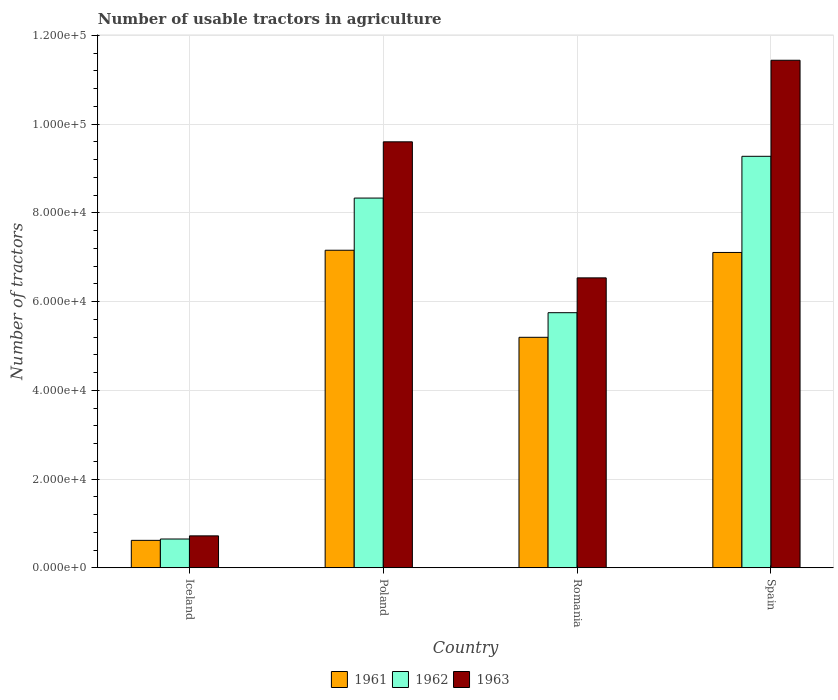Are the number of bars per tick equal to the number of legend labels?
Your response must be concise. Yes. What is the label of the 1st group of bars from the left?
Make the answer very short. Iceland. What is the number of usable tractors in agriculture in 1961 in Iceland?
Provide a short and direct response. 6177. Across all countries, what is the maximum number of usable tractors in agriculture in 1961?
Give a very brief answer. 7.16e+04. Across all countries, what is the minimum number of usable tractors in agriculture in 1962?
Your answer should be very brief. 6479. What is the total number of usable tractors in agriculture in 1962 in the graph?
Provide a succinct answer. 2.40e+05. What is the difference between the number of usable tractors in agriculture in 1961 in Iceland and that in Spain?
Offer a very short reply. -6.49e+04. What is the difference between the number of usable tractors in agriculture in 1963 in Poland and the number of usable tractors in agriculture in 1962 in Romania?
Ensure brevity in your answer.  3.85e+04. What is the average number of usable tractors in agriculture in 1963 per country?
Your response must be concise. 7.07e+04. What is the difference between the number of usable tractors in agriculture of/in 1961 and number of usable tractors in agriculture of/in 1962 in Iceland?
Keep it short and to the point. -302. In how many countries, is the number of usable tractors in agriculture in 1961 greater than 100000?
Offer a terse response. 0. What is the ratio of the number of usable tractors in agriculture in 1961 in Romania to that in Spain?
Keep it short and to the point. 0.73. Is the number of usable tractors in agriculture in 1963 in Poland less than that in Spain?
Keep it short and to the point. Yes. What is the difference between the highest and the second highest number of usable tractors in agriculture in 1961?
Make the answer very short. -1.96e+04. What is the difference between the highest and the lowest number of usable tractors in agriculture in 1962?
Offer a very short reply. 8.63e+04. Is the sum of the number of usable tractors in agriculture in 1963 in Poland and Spain greater than the maximum number of usable tractors in agriculture in 1962 across all countries?
Your response must be concise. Yes. What does the 3rd bar from the right in Spain represents?
Ensure brevity in your answer.  1961. Is it the case that in every country, the sum of the number of usable tractors in agriculture in 1963 and number of usable tractors in agriculture in 1961 is greater than the number of usable tractors in agriculture in 1962?
Your answer should be very brief. Yes. Are all the bars in the graph horizontal?
Keep it short and to the point. No. What is the difference between two consecutive major ticks on the Y-axis?
Your answer should be compact. 2.00e+04. Are the values on the major ticks of Y-axis written in scientific E-notation?
Offer a terse response. Yes. Does the graph contain any zero values?
Ensure brevity in your answer.  No. Does the graph contain grids?
Ensure brevity in your answer.  Yes. How are the legend labels stacked?
Your answer should be very brief. Horizontal. What is the title of the graph?
Your response must be concise. Number of usable tractors in agriculture. Does "1995" appear as one of the legend labels in the graph?
Make the answer very short. No. What is the label or title of the X-axis?
Offer a very short reply. Country. What is the label or title of the Y-axis?
Make the answer very short. Number of tractors. What is the Number of tractors in 1961 in Iceland?
Give a very brief answer. 6177. What is the Number of tractors of 1962 in Iceland?
Make the answer very short. 6479. What is the Number of tractors in 1963 in Iceland?
Your response must be concise. 7187. What is the Number of tractors of 1961 in Poland?
Provide a succinct answer. 7.16e+04. What is the Number of tractors in 1962 in Poland?
Offer a terse response. 8.33e+04. What is the Number of tractors in 1963 in Poland?
Offer a terse response. 9.60e+04. What is the Number of tractors in 1961 in Romania?
Your response must be concise. 5.20e+04. What is the Number of tractors of 1962 in Romania?
Provide a succinct answer. 5.75e+04. What is the Number of tractors of 1963 in Romania?
Your answer should be very brief. 6.54e+04. What is the Number of tractors in 1961 in Spain?
Provide a short and direct response. 7.11e+04. What is the Number of tractors of 1962 in Spain?
Keep it short and to the point. 9.28e+04. What is the Number of tractors of 1963 in Spain?
Keep it short and to the point. 1.14e+05. Across all countries, what is the maximum Number of tractors of 1961?
Your response must be concise. 7.16e+04. Across all countries, what is the maximum Number of tractors of 1962?
Make the answer very short. 9.28e+04. Across all countries, what is the maximum Number of tractors of 1963?
Your answer should be compact. 1.14e+05. Across all countries, what is the minimum Number of tractors in 1961?
Keep it short and to the point. 6177. Across all countries, what is the minimum Number of tractors in 1962?
Offer a terse response. 6479. Across all countries, what is the minimum Number of tractors of 1963?
Your answer should be compact. 7187. What is the total Number of tractors of 1961 in the graph?
Ensure brevity in your answer.  2.01e+05. What is the total Number of tractors in 1962 in the graph?
Make the answer very short. 2.40e+05. What is the total Number of tractors of 1963 in the graph?
Provide a short and direct response. 2.83e+05. What is the difference between the Number of tractors in 1961 in Iceland and that in Poland?
Provide a short and direct response. -6.54e+04. What is the difference between the Number of tractors of 1962 in Iceland and that in Poland?
Your answer should be very brief. -7.69e+04. What is the difference between the Number of tractors in 1963 in Iceland and that in Poland?
Make the answer very short. -8.88e+04. What is the difference between the Number of tractors of 1961 in Iceland and that in Romania?
Ensure brevity in your answer.  -4.58e+04. What is the difference between the Number of tractors of 1962 in Iceland and that in Romania?
Your answer should be very brief. -5.10e+04. What is the difference between the Number of tractors in 1963 in Iceland and that in Romania?
Offer a terse response. -5.82e+04. What is the difference between the Number of tractors of 1961 in Iceland and that in Spain?
Make the answer very short. -6.49e+04. What is the difference between the Number of tractors in 1962 in Iceland and that in Spain?
Give a very brief answer. -8.63e+04. What is the difference between the Number of tractors of 1963 in Iceland and that in Spain?
Make the answer very short. -1.07e+05. What is the difference between the Number of tractors in 1961 in Poland and that in Romania?
Provide a succinct answer. 1.96e+04. What is the difference between the Number of tractors of 1962 in Poland and that in Romania?
Your response must be concise. 2.58e+04. What is the difference between the Number of tractors of 1963 in Poland and that in Romania?
Keep it short and to the point. 3.07e+04. What is the difference between the Number of tractors in 1961 in Poland and that in Spain?
Provide a succinct answer. 500. What is the difference between the Number of tractors in 1962 in Poland and that in Spain?
Provide a succinct answer. -9414. What is the difference between the Number of tractors of 1963 in Poland and that in Spain?
Make the answer very short. -1.84e+04. What is the difference between the Number of tractors in 1961 in Romania and that in Spain?
Ensure brevity in your answer.  -1.91e+04. What is the difference between the Number of tractors in 1962 in Romania and that in Spain?
Give a very brief answer. -3.53e+04. What is the difference between the Number of tractors of 1963 in Romania and that in Spain?
Provide a succinct answer. -4.91e+04. What is the difference between the Number of tractors in 1961 in Iceland and the Number of tractors in 1962 in Poland?
Your answer should be very brief. -7.72e+04. What is the difference between the Number of tractors in 1961 in Iceland and the Number of tractors in 1963 in Poland?
Provide a succinct answer. -8.98e+04. What is the difference between the Number of tractors of 1962 in Iceland and the Number of tractors of 1963 in Poland?
Provide a short and direct response. -8.95e+04. What is the difference between the Number of tractors in 1961 in Iceland and the Number of tractors in 1962 in Romania?
Provide a short and direct response. -5.13e+04. What is the difference between the Number of tractors in 1961 in Iceland and the Number of tractors in 1963 in Romania?
Offer a terse response. -5.92e+04. What is the difference between the Number of tractors of 1962 in Iceland and the Number of tractors of 1963 in Romania?
Provide a short and direct response. -5.89e+04. What is the difference between the Number of tractors of 1961 in Iceland and the Number of tractors of 1962 in Spain?
Provide a succinct answer. -8.66e+04. What is the difference between the Number of tractors in 1961 in Iceland and the Number of tractors in 1963 in Spain?
Keep it short and to the point. -1.08e+05. What is the difference between the Number of tractors in 1962 in Iceland and the Number of tractors in 1963 in Spain?
Your answer should be compact. -1.08e+05. What is the difference between the Number of tractors in 1961 in Poland and the Number of tractors in 1962 in Romania?
Your answer should be very brief. 1.41e+04. What is the difference between the Number of tractors in 1961 in Poland and the Number of tractors in 1963 in Romania?
Your response must be concise. 6226. What is the difference between the Number of tractors of 1962 in Poland and the Number of tractors of 1963 in Romania?
Offer a very short reply. 1.80e+04. What is the difference between the Number of tractors of 1961 in Poland and the Number of tractors of 1962 in Spain?
Your answer should be compact. -2.12e+04. What is the difference between the Number of tractors of 1961 in Poland and the Number of tractors of 1963 in Spain?
Provide a succinct answer. -4.28e+04. What is the difference between the Number of tractors of 1962 in Poland and the Number of tractors of 1963 in Spain?
Keep it short and to the point. -3.11e+04. What is the difference between the Number of tractors in 1961 in Romania and the Number of tractors in 1962 in Spain?
Keep it short and to the point. -4.08e+04. What is the difference between the Number of tractors of 1961 in Romania and the Number of tractors of 1963 in Spain?
Your answer should be very brief. -6.25e+04. What is the difference between the Number of tractors of 1962 in Romania and the Number of tractors of 1963 in Spain?
Ensure brevity in your answer.  -5.69e+04. What is the average Number of tractors in 1961 per country?
Ensure brevity in your answer.  5.02e+04. What is the average Number of tractors in 1962 per country?
Offer a terse response. 6.00e+04. What is the average Number of tractors in 1963 per country?
Your response must be concise. 7.07e+04. What is the difference between the Number of tractors in 1961 and Number of tractors in 1962 in Iceland?
Provide a short and direct response. -302. What is the difference between the Number of tractors in 1961 and Number of tractors in 1963 in Iceland?
Provide a short and direct response. -1010. What is the difference between the Number of tractors in 1962 and Number of tractors in 1963 in Iceland?
Your answer should be very brief. -708. What is the difference between the Number of tractors in 1961 and Number of tractors in 1962 in Poland?
Make the answer very short. -1.18e+04. What is the difference between the Number of tractors in 1961 and Number of tractors in 1963 in Poland?
Ensure brevity in your answer.  -2.44e+04. What is the difference between the Number of tractors of 1962 and Number of tractors of 1963 in Poland?
Ensure brevity in your answer.  -1.27e+04. What is the difference between the Number of tractors of 1961 and Number of tractors of 1962 in Romania?
Keep it short and to the point. -5548. What is the difference between the Number of tractors of 1961 and Number of tractors of 1963 in Romania?
Offer a terse response. -1.34e+04. What is the difference between the Number of tractors of 1962 and Number of tractors of 1963 in Romania?
Provide a succinct answer. -7851. What is the difference between the Number of tractors in 1961 and Number of tractors in 1962 in Spain?
Your answer should be very brief. -2.17e+04. What is the difference between the Number of tractors of 1961 and Number of tractors of 1963 in Spain?
Ensure brevity in your answer.  -4.33e+04. What is the difference between the Number of tractors in 1962 and Number of tractors in 1963 in Spain?
Ensure brevity in your answer.  -2.17e+04. What is the ratio of the Number of tractors of 1961 in Iceland to that in Poland?
Offer a terse response. 0.09. What is the ratio of the Number of tractors of 1962 in Iceland to that in Poland?
Provide a succinct answer. 0.08. What is the ratio of the Number of tractors in 1963 in Iceland to that in Poland?
Provide a succinct answer. 0.07. What is the ratio of the Number of tractors in 1961 in Iceland to that in Romania?
Your answer should be very brief. 0.12. What is the ratio of the Number of tractors of 1962 in Iceland to that in Romania?
Your answer should be compact. 0.11. What is the ratio of the Number of tractors in 1963 in Iceland to that in Romania?
Your response must be concise. 0.11. What is the ratio of the Number of tractors of 1961 in Iceland to that in Spain?
Give a very brief answer. 0.09. What is the ratio of the Number of tractors in 1962 in Iceland to that in Spain?
Make the answer very short. 0.07. What is the ratio of the Number of tractors of 1963 in Iceland to that in Spain?
Make the answer very short. 0.06. What is the ratio of the Number of tractors in 1961 in Poland to that in Romania?
Offer a terse response. 1.38. What is the ratio of the Number of tractors of 1962 in Poland to that in Romania?
Keep it short and to the point. 1.45. What is the ratio of the Number of tractors in 1963 in Poland to that in Romania?
Offer a very short reply. 1.47. What is the ratio of the Number of tractors of 1962 in Poland to that in Spain?
Offer a very short reply. 0.9. What is the ratio of the Number of tractors in 1963 in Poland to that in Spain?
Your answer should be compact. 0.84. What is the ratio of the Number of tractors in 1961 in Romania to that in Spain?
Give a very brief answer. 0.73. What is the ratio of the Number of tractors of 1962 in Romania to that in Spain?
Offer a very short reply. 0.62. What is the ratio of the Number of tractors in 1963 in Romania to that in Spain?
Offer a very short reply. 0.57. What is the difference between the highest and the second highest Number of tractors of 1962?
Offer a terse response. 9414. What is the difference between the highest and the second highest Number of tractors of 1963?
Make the answer very short. 1.84e+04. What is the difference between the highest and the lowest Number of tractors in 1961?
Keep it short and to the point. 6.54e+04. What is the difference between the highest and the lowest Number of tractors in 1962?
Give a very brief answer. 8.63e+04. What is the difference between the highest and the lowest Number of tractors in 1963?
Give a very brief answer. 1.07e+05. 